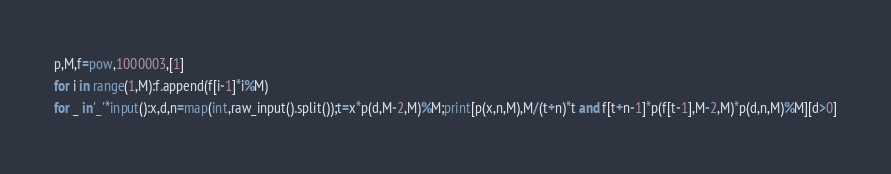<code> <loc_0><loc_0><loc_500><loc_500><_Python_>p,M,f=pow,1000003,[1]
for i in range(1,M):f.append(f[i-1]*i%M)
for _ in'_'*input():x,d,n=map(int,raw_input().split());t=x*p(d,M-2,M)%M;print[p(x,n,M),M/(t+n)*t and f[t+n-1]*p(f[t-1],M-2,M)*p(d,n,M)%M][d>0]</code> 